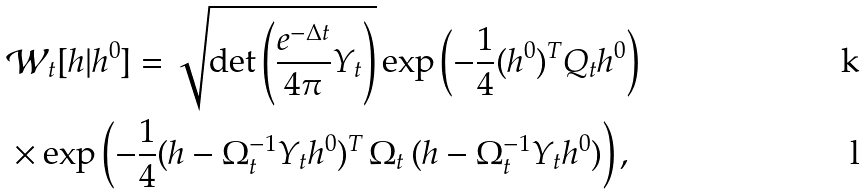Convert formula to latex. <formula><loc_0><loc_0><loc_500><loc_500>& \mathcal { W } _ { t } [ h | h ^ { 0 } ] = \sqrt { \det \left ( \frac { e ^ { - \Delta t } } { 4 \pi } Y _ { t } \right ) } \exp \left ( - \frac { 1 } { 4 } ( h ^ { 0 } ) ^ { T } Q _ { t } h ^ { 0 } \right ) \\ & \times \exp \left ( - \frac { 1 } { 4 } ( h - \Omega _ { t } ^ { - 1 } Y _ { t } h ^ { 0 } ) ^ { T } \, \Omega _ { t } \, ( h - \Omega _ { t } ^ { - 1 } Y _ { t } h ^ { 0 } ) \right ) ,</formula> 